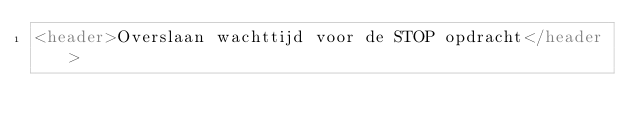<code> <loc_0><loc_0><loc_500><loc_500><_HTML_><header>Overslaan wachttijd voor de STOP opdracht</header>
</code> 